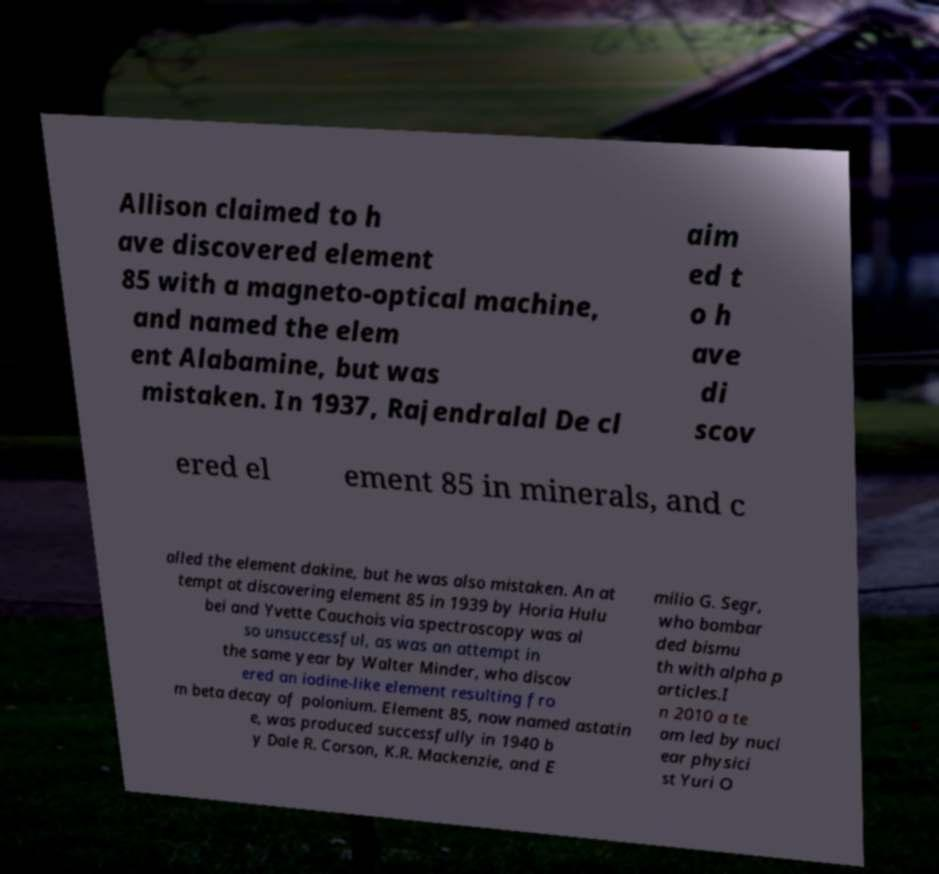Please read and relay the text visible in this image. What does it say? Allison claimed to h ave discovered element 85 with a magneto-optical machine, and named the elem ent Alabamine, but was mistaken. In 1937, Rajendralal De cl aim ed t o h ave di scov ered el ement 85 in minerals, and c alled the element dakine, but he was also mistaken. An at tempt at discovering element 85 in 1939 by Horia Hulu bei and Yvette Cauchois via spectroscopy was al so unsuccessful, as was an attempt in the same year by Walter Minder, who discov ered an iodine-like element resulting fro m beta decay of polonium. Element 85, now named astatin e, was produced successfully in 1940 b y Dale R. Corson, K.R. Mackenzie, and E milio G. Segr, who bombar ded bismu th with alpha p articles.I n 2010 a te am led by nucl ear physici st Yuri O 